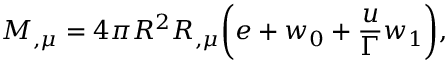<formula> <loc_0><loc_0><loc_500><loc_500>M _ { , \mu } = 4 \pi R ^ { 2 } R _ { , \mu } \left ( { e + w _ { 0 } + { \frac { u } { \Gamma } } w _ { 1 } } \right ) ,</formula> 